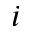Convert formula to latex. <formula><loc_0><loc_0><loc_500><loc_500>i</formula> 